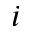Convert formula to latex. <formula><loc_0><loc_0><loc_500><loc_500>i</formula> 